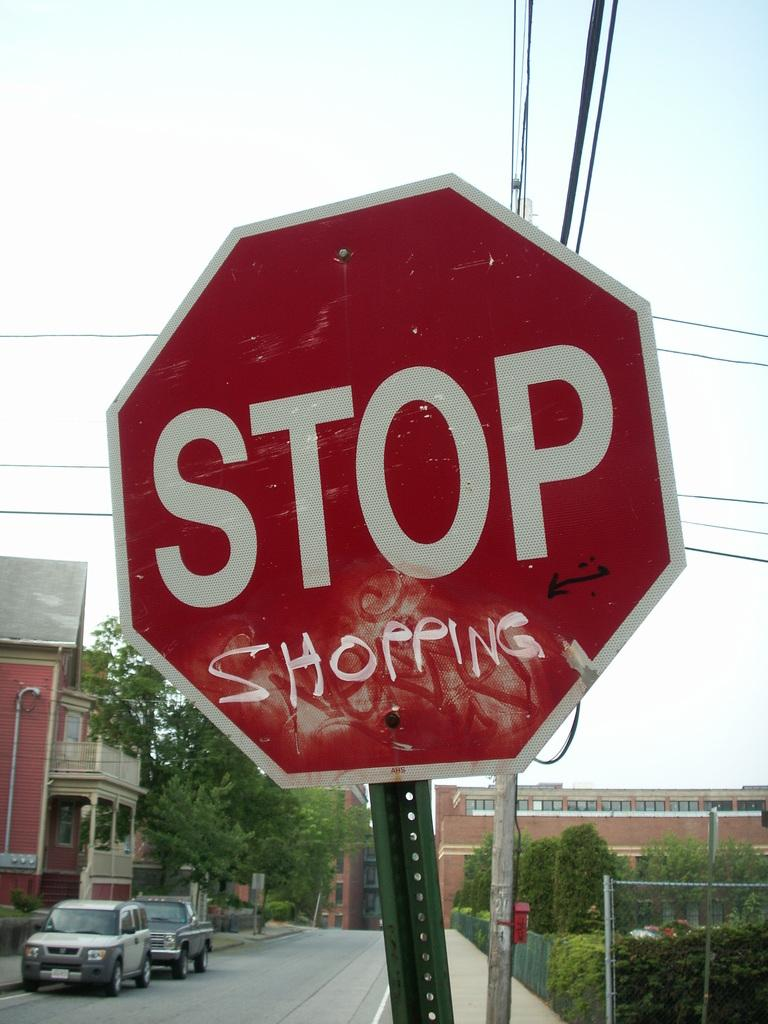<image>
Share a concise interpretation of the image provided. The word shopping is painted on a stop sign underneath the word stop. 